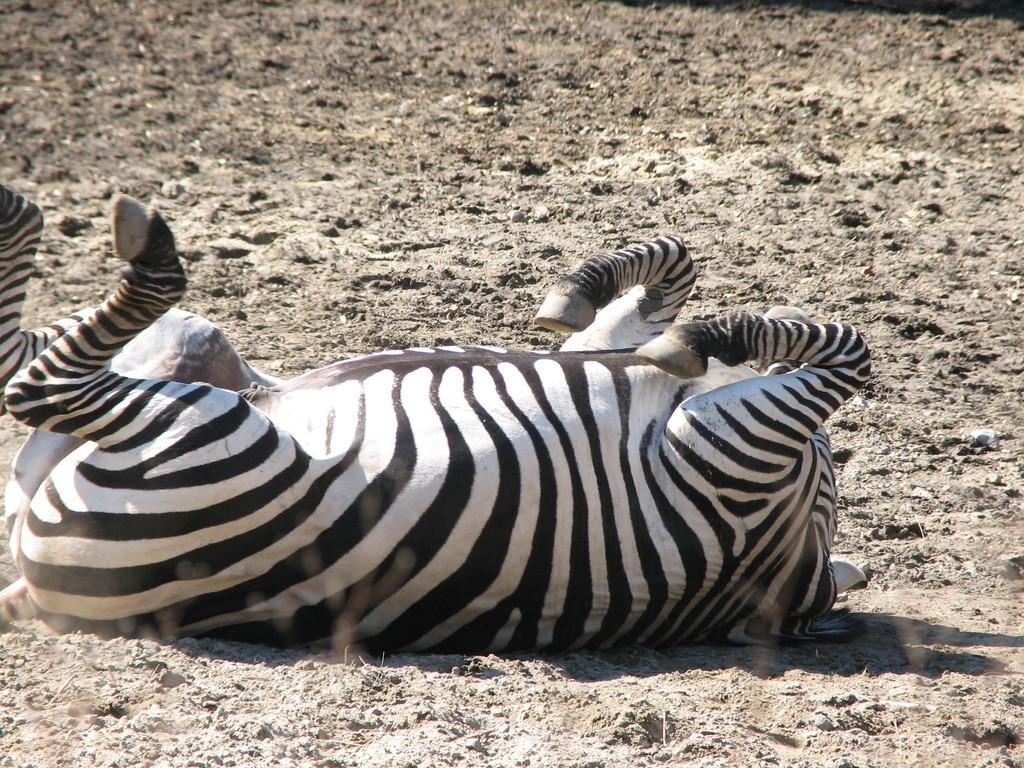Please provide a concise description of this image. In this image I can see the zebra on the ground. The zebra is in white and black color. 